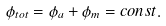Convert formula to latex. <formula><loc_0><loc_0><loc_500><loc_500>\phi _ { t o t } = \phi _ { a } + \phi _ { m } = c o n s t .</formula> 